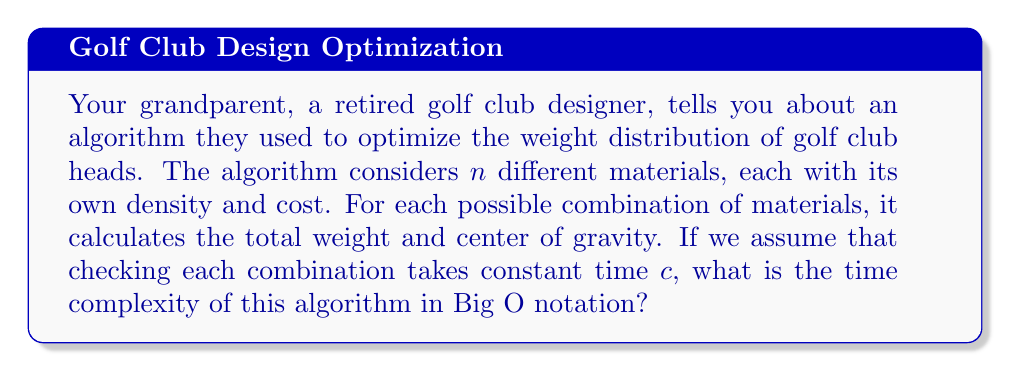Provide a solution to this math problem. Let's approach this step-by-step:

1) First, we need to understand what the algorithm is doing. It's considering all possible combinations of $n$ materials.

2) In combinatorics, when we're selecting all possible combinations of items, where each item can either be selected or not selected, we're dealing with the power set.

3) The size of the power set of a set with $n$ elements is $2^n$. This is because for each element, we have two choices: include it or don't include it.

4) So, the algorithm needs to check $2^n$ combinations.

5) For each combination, the algorithm performs some calculations that take constant time $c$.

6) Therefore, the total time taken by the algorithm is:

   $$T(n) = c \cdot 2^n$$

7) In Big O notation, we drop constant factors. So $c$ can be ignored.

8) This leaves us with $O(2^n)$.

This is an exponential time complexity, which means the time taken by the algorithm grows very rapidly as $n$ increases. It's not efficient for large values of $n$, which explains why modern golf club design often uses more sophisticated optimization techniques.
Answer: $O(2^n)$ 